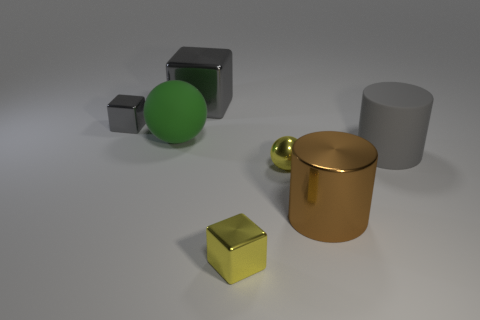Subtract all gray balls. How many gray blocks are left? 2 Add 2 big yellow metallic balls. How many objects exist? 9 Subtract all gray blocks. How many blocks are left? 1 Subtract 1 blocks. How many blocks are left? 2 Add 3 large metallic objects. How many large metallic objects exist? 5 Subtract 0 cyan balls. How many objects are left? 7 Subtract all balls. How many objects are left? 5 Subtract all cyan cubes. Subtract all blue cylinders. How many cubes are left? 3 Subtract all big brown shiny spheres. Subtract all yellow spheres. How many objects are left? 6 Add 4 small yellow shiny cubes. How many small yellow shiny cubes are left? 5 